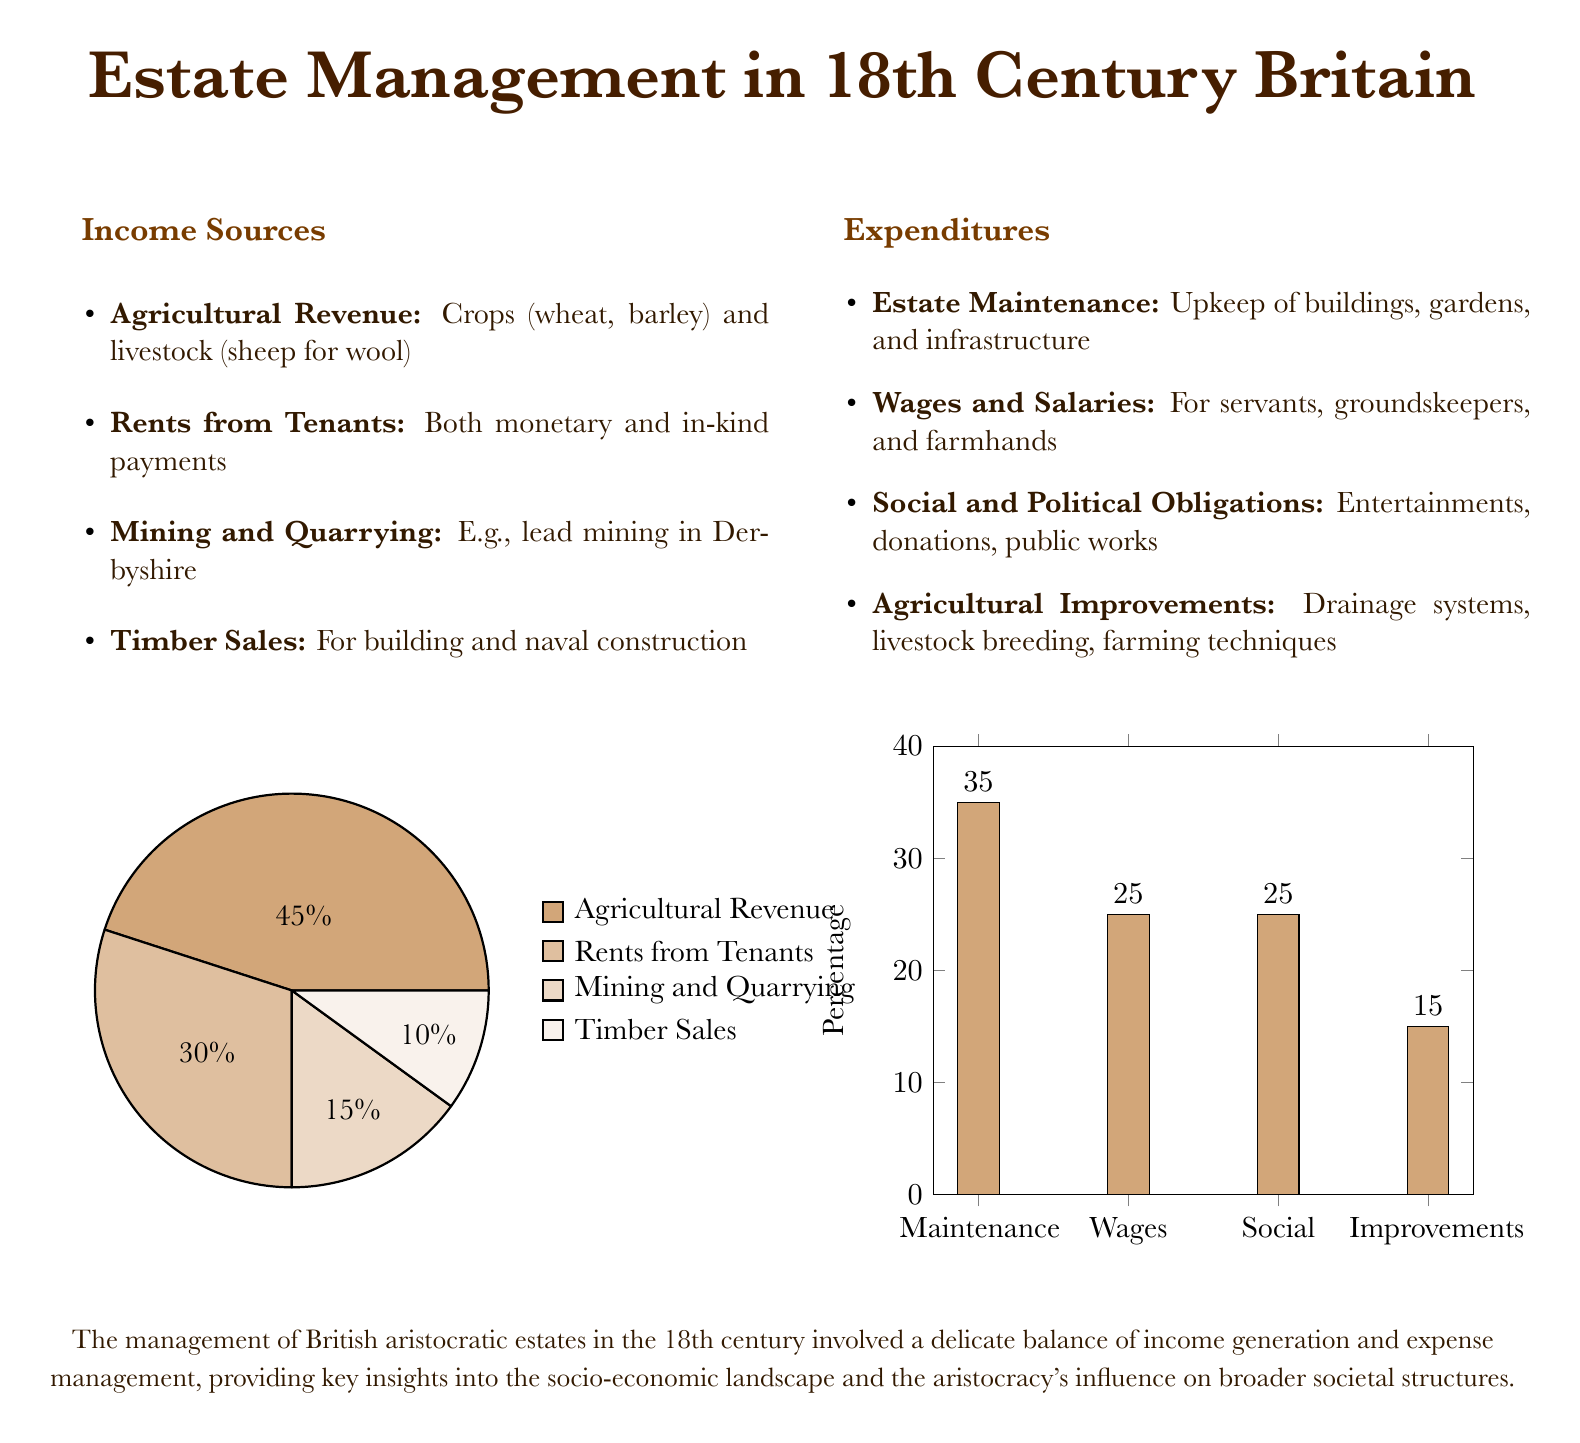What is the largest source of income? The largest source of income is identified in the pie chart representing the income sources, which shows Agricultural Revenue as 45%.
Answer: Agricultural Revenue What percentage of expenditures is allocated to Estate Maintenance? The bar chart for expenditures indicates that Estate Maintenance accounts for 35% of total expenditures.
Answer: 35% What type of revenue comes from leasing land to tenants? The income source from leasing land is categorized under Rents from Tenants.
Answer: Rents from Tenants How much of the total income comes from Mining and Quarrying? The pie chart shows that Mining and Quarrying constitutes 15% of the total income sources.
Answer: 15% Which category of expenditure is equivalent to both Wages and Social obligations? The document states that both Wages and Social obligations each account for 25% of total expenditures.
Answer: 25% What visual representation is used to show income sources? The visual representation used for income sources is a pie chart.
Answer: Pie chart What is the smallest source of income listed? The smallest source of income from the pie chart is Timber Sales, which accounts for 10%.
Answer: Timber Sales What percentage of expenditures is related to Agricultural Improvements? The bar chart reveals that Agricultural Improvements are allocated 15% of total expenditures.
Answer: 15% Which revenue source is primarily related to land farming? The revenue source primarily related to land farming is Agricultural Revenue.
Answer: Agricultural Revenue 